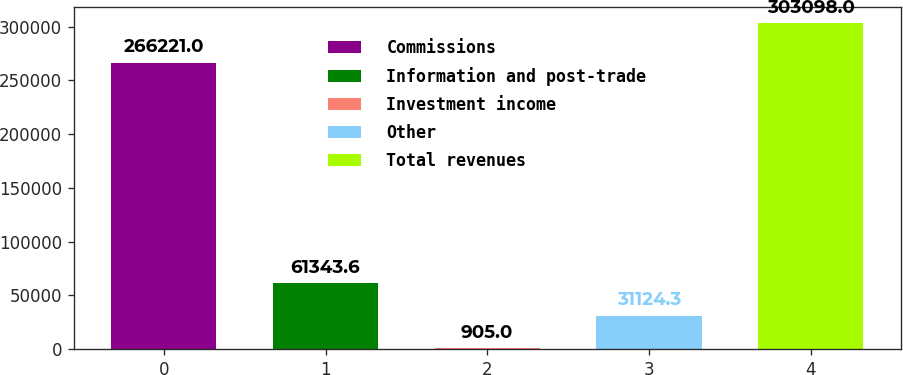Convert chart to OTSL. <chart><loc_0><loc_0><loc_500><loc_500><bar_chart><fcel>Commissions<fcel>Information and post-trade<fcel>Investment income<fcel>Other<fcel>Total revenues<nl><fcel>266221<fcel>61343.6<fcel>905<fcel>31124.3<fcel>303098<nl></chart> 